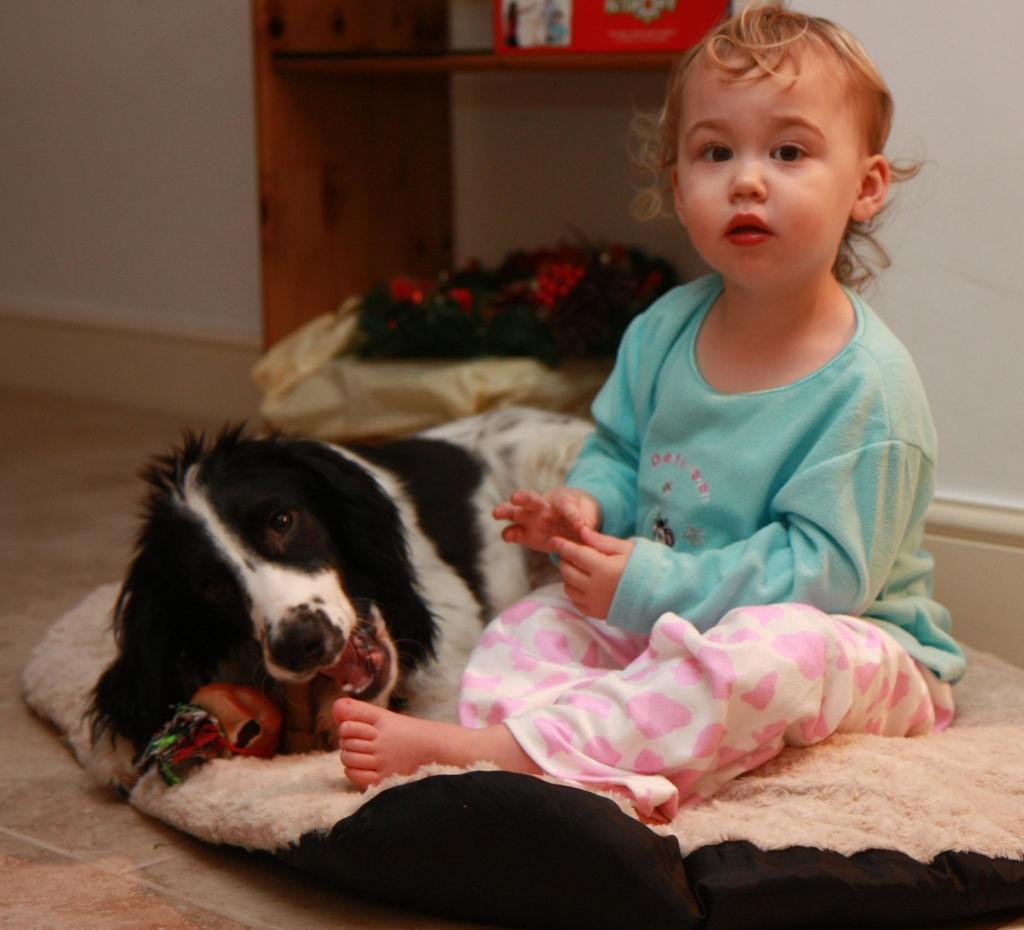How would you summarize this image in a sentence or two? In the foreground of this image, there is a girl and a dog on a dog bed. In the background, there are desk, cardboard box, wall and a bouquet. 